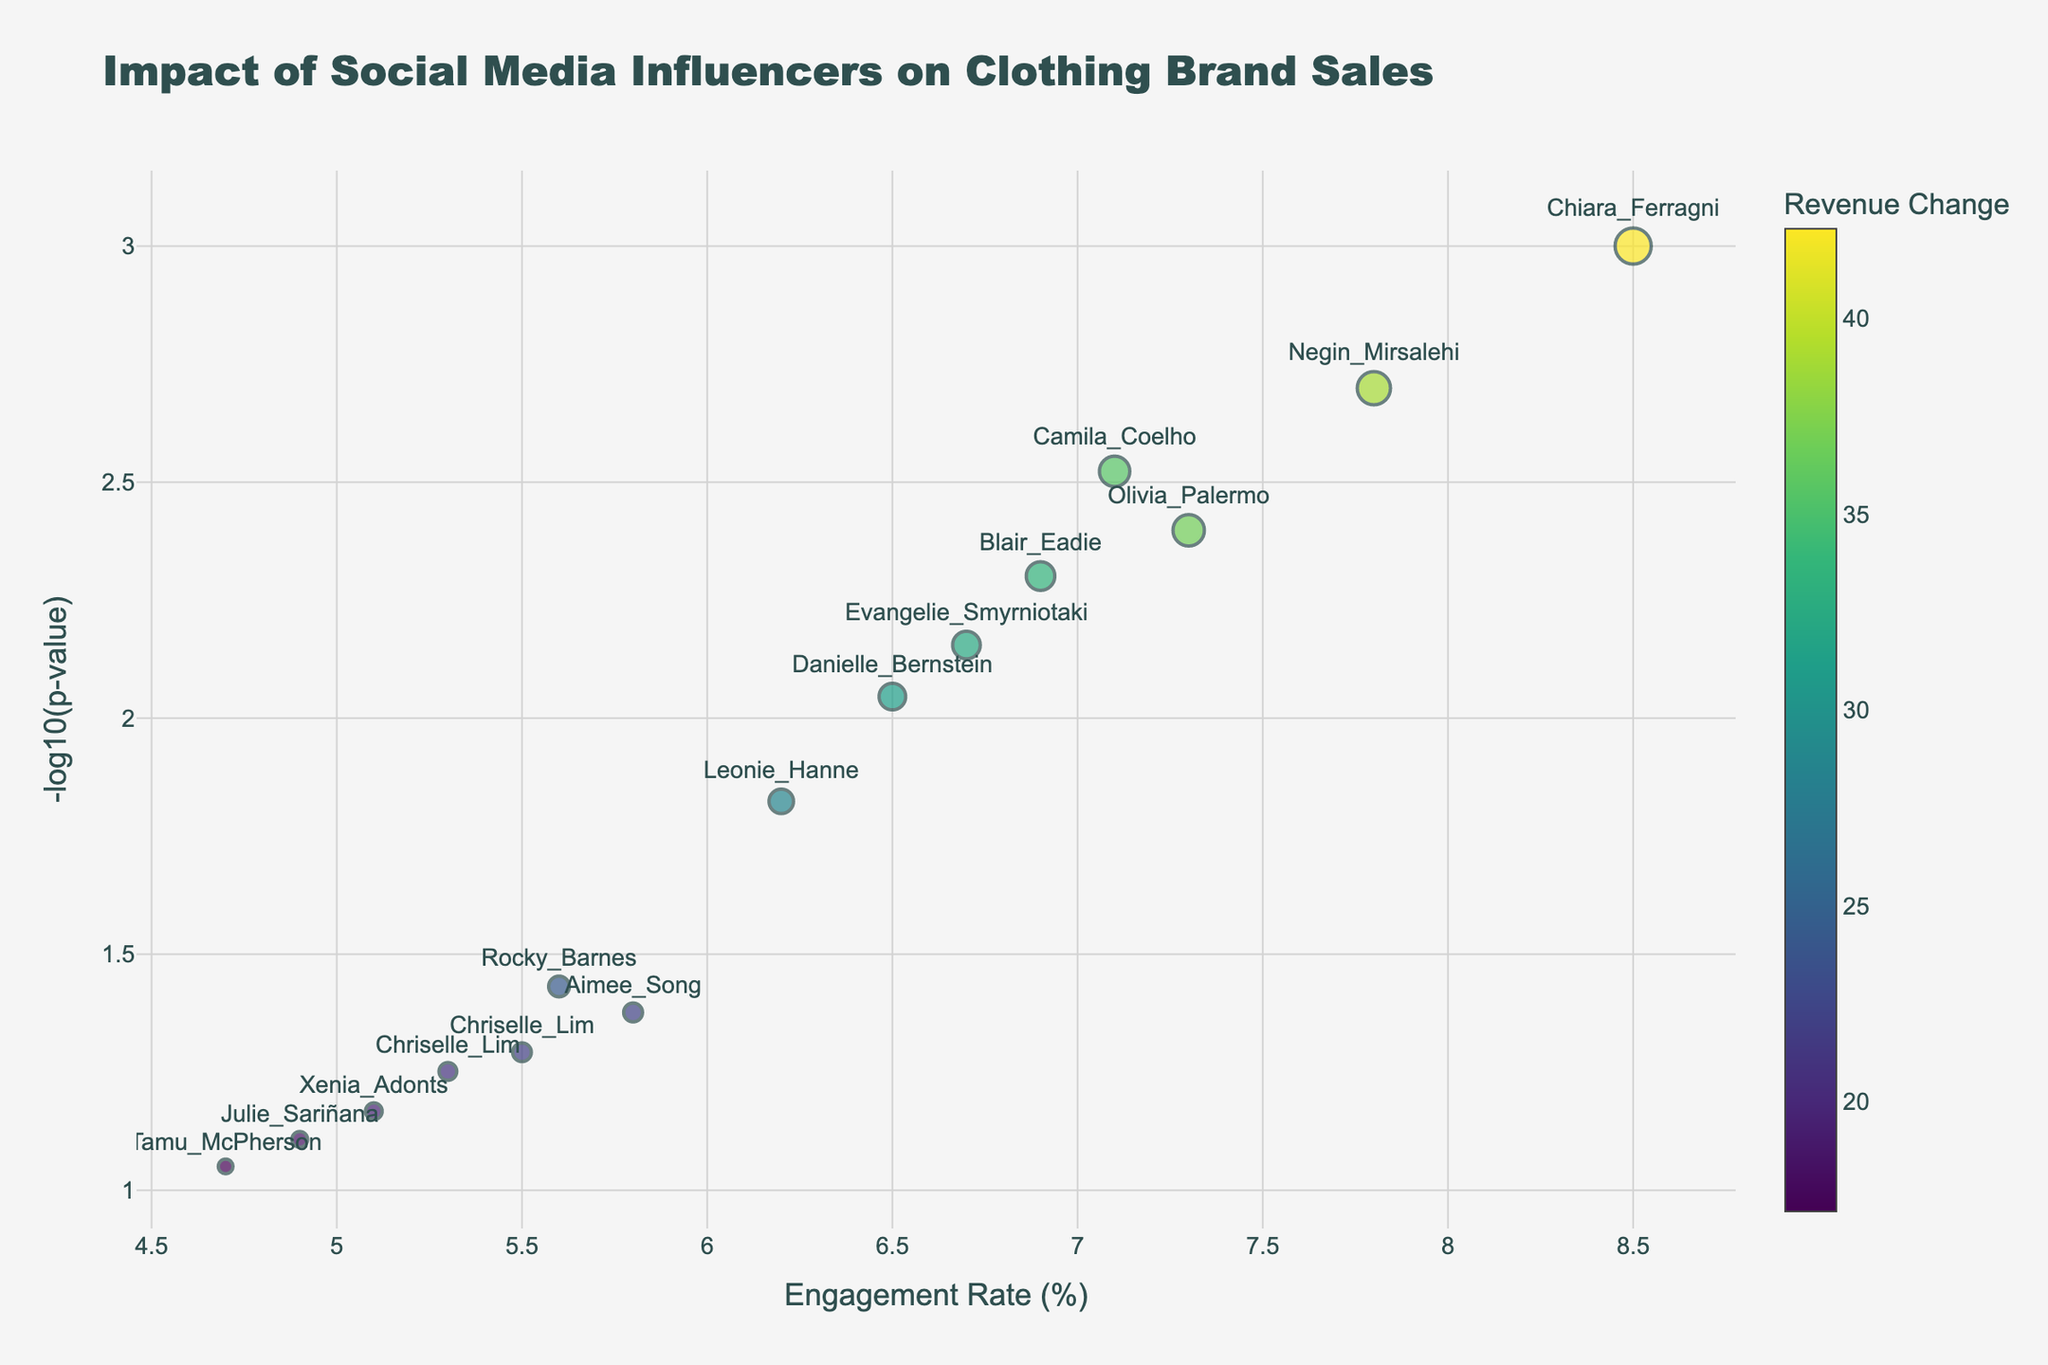How many influencers are displayed in the figure? Count the number of labeled data points (influencers) visible in the plot.
Answer: 15 What is the title of the figure? Look at the top of the plot for the bolded text indicating the title.
Answer: Impact of Social Media Influencers on Clothing Brand Sales Where is the engagement rate located on the figure? The engagement rate is represented on the x-axis at the bottom of the plot.
Answer: x-axis Which influencer has the highest engagement rate? Identify the influencer whose data point is located the furthest to the right on the x-axis.
Answer: Chiara Ferragni What is the P-Value for Julie Sariñana? Hover over Julie Sariñana's data point to see the hover template information which includes the P-Value.
Answer: 0.078 Which influencer shows the most significant positive impact on revenue change? Find the influencer with the largest bubble size and highest value on the color scale.
Answer: Chiara Ferragni Compare the engagement rates between Aimee Song and Olivia Palermo. Which one is higher? Locate the positions of Aimee Song and Olivia Palermo on the x-axis and compare.
Answer: Olivia Palermo What is the revenue change for Rocky Barnes? Hover over Rocky Barnes's data point to see the hover template information which includes revenue change.
Answer: 24.3 Identify the influencer with an engagement rate of 6.9 and discuss their revenue change. Look for the data point at 6.9 on the x-axis and find the influencer name and their revenue change from the hover template.
Answer: Blair Eadie, 33.5 Which influencer has a close to average engagement rate and also high -log10(p-value) score? Identify the influencer near the middle of the x-axis with a higher position on the y-axis.
Answer: Chriselle Lim 